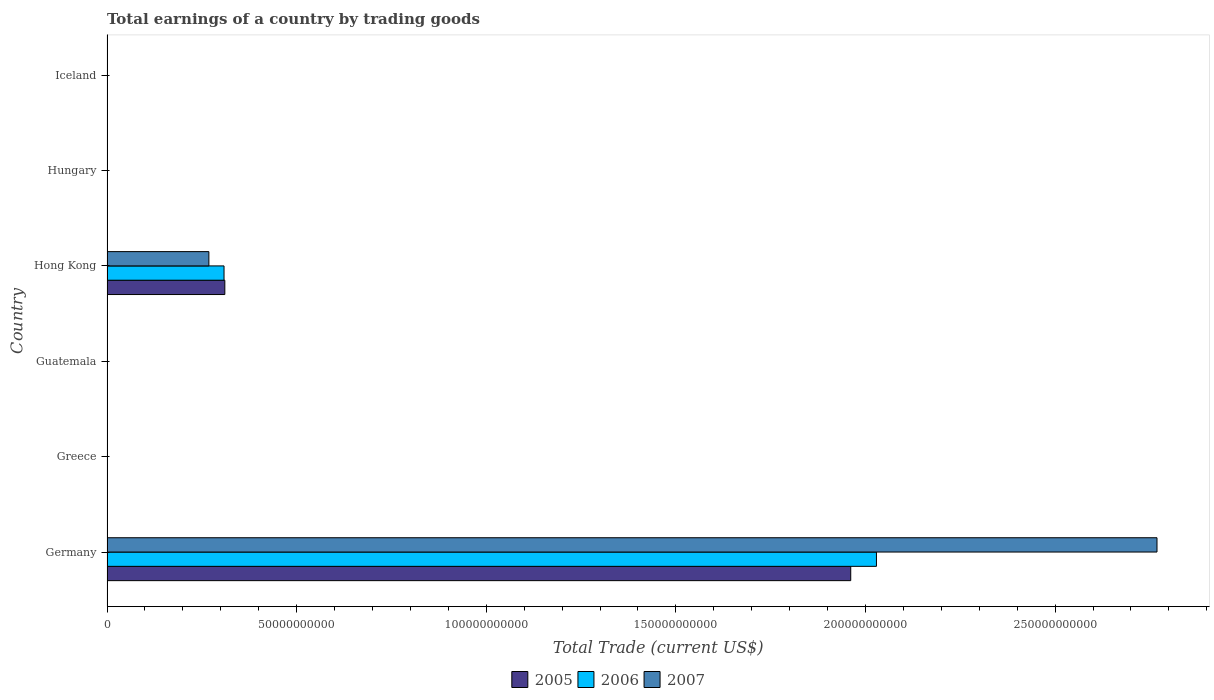How many bars are there on the 3rd tick from the top?
Your answer should be very brief. 3. How many bars are there on the 4th tick from the bottom?
Ensure brevity in your answer.  3. In how many cases, is the number of bars for a given country not equal to the number of legend labels?
Give a very brief answer. 4. What is the total earnings in 2007 in Germany?
Keep it short and to the point. 2.77e+11. Across all countries, what is the maximum total earnings in 2005?
Provide a succinct answer. 1.96e+11. What is the total total earnings in 2007 in the graph?
Your response must be concise. 3.04e+11. What is the difference between the total earnings in 2005 in Germany and that in Hong Kong?
Your answer should be very brief. 1.65e+11. What is the difference between the total earnings in 2006 in Hong Kong and the total earnings in 2005 in Iceland?
Provide a short and direct response. 3.09e+1. What is the average total earnings in 2005 per country?
Offer a very short reply. 3.79e+1. What is the difference between the total earnings in 2005 and total earnings in 2006 in Hong Kong?
Your answer should be very brief. 2.11e+08. What is the ratio of the total earnings in 2006 in Germany to that in Hong Kong?
Your answer should be very brief. 6.58. What is the difference between the highest and the lowest total earnings in 2005?
Provide a short and direct response. 1.96e+11. How many countries are there in the graph?
Your response must be concise. 6. Does the graph contain any zero values?
Offer a very short reply. Yes. Does the graph contain grids?
Provide a succinct answer. No. How many legend labels are there?
Provide a succinct answer. 3. How are the legend labels stacked?
Provide a succinct answer. Horizontal. What is the title of the graph?
Provide a succinct answer. Total earnings of a country by trading goods. Does "1963" appear as one of the legend labels in the graph?
Your answer should be very brief. No. What is the label or title of the X-axis?
Make the answer very short. Total Trade (current US$). What is the Total Trade (current US$) in 2005 in Germany?
Provide a short and direct response. 1.96e+11. What is the Total Trade (current US$) of 2006 in Germany?
Ensure brevity in your answer.  2.03e+11. What is the Total Trade (current US$) in 2007 in Germany?
Offer a terse response. 2.77e+11. What is the Total Trade (current US$) of 2005 in Guatemala?
Your answer should be compact. 0. What is the Total Trade (current US$) of 2006 in Guatemala?
Keep it short and to the point. 0. What is the Total Trade (current US$) in 2007 in Guatemala?
Keep it short and to the point. 0. What is the Total Trade (current US$) in 2005 in Hong Kong?
Your response must be concise. 3.11e+1. What is the Total Trade (current US$) in 2006 in Hong Kong?
Provide a succinct answer. 3.09e+1. What is the Total Trade (current US$) in 2007 in Hong Kong?
Offer a very short reply. 2.69e+1. What is the Total Trade (current US$) in 2006 in Hungary?
Offer a very short reply. 0. What is the Total Trade (current US$) of 2007 in Hungary?
Your answer should be very brief. 0. What is the Total Trade (current US$) of 2006 in Iceland?
Give a very brief answer. 0. Across all countries, what is the maximum Total Trade (current US$) in 2005?
Ensure brevity in your answer.  1.96e+11. Across all countries, what is the maximum Total Trade (current US$) in 2006?
Your answer should be very brief. 2.03e+11. Across all countries, what is the maximum Total Trade (current US$) of 2007?
Your response must be concise. 2.77e+11. What is the total Total Trade (current US$) of 2005 in the graph?
Keep it short and to the point. 2.27e+11. What is the total Total Trade (current US$) of 2006 in the graph?
Provide a short and direct response. 2.34e+11. What is the total Total Trade (current US$) in 2007 in the graph?
Offer a terse response. 3.04e+11. What is the difference between the Total Trade (current US$) in 2005 in Germany and that in Hong Kong?
Ensure brevity in your answer.  1.65e+11. What is the difference between the Total Trade (current US$) of 2006 in Germany and that in Hong Kong?
Provide a short and direct response. 1.72e+11. What is the difference between the Total Trade (current US$) in 2007 in Germany and that in Hong Kong?
Keep it short and to the point. 2.50e+11. What is the difference between the Total Trade (current US$) in 2005 in Germany and the Total Trade (current US$) in 2006 in Hong Kong?
Your response must be concise. 1.65e+11. What is the difference between the Total Trade (current US$) of 2005 in Germany and the Total Trade (current US$) of 2007 in Hong Kong?
Give a very brief answer. 1.69e+11. What is the difference between the Total Trade (current US$) in 2006 in Germany and the Total Trade (current US$) in 2007 in Hong Kong?
Make the answer very short. 1.76e+11. What is the average Total Trade (current US$) in 2005 per country?
Your answer should be compact. 3.79e+1. What is the average Total Trade (current US$) of 2006 per country?
Your response must be concise. 3.90e+1. What is the average Total Trade (current US$) in 2007 per country?
Provide a short and direct response. 5.06e+1. What is the difference between the Total Trade (current US$) in 2005 and Total Trade (current US$) in 2006 in Germany?
Offer a terse response. -6.78e+09. What is the difference between the Total Trade (current US$) of 2005 and Total Trade (current US$) of 2007 in Germany?
Your answer should be very brief. -8.08e+1. What is the difference between the Total Trade (current US$) of 2006 and Total Trade (current US$) of 2007 in Germany?
Provide a succinct answer. -7.40e+1. What is the difference between the Total Trade (current US$) of 2005 and Total Trade (current US$) of 2006 in Hong Kong?
Provide a succinct answer. 2.11e+08. What is the difference between the Total Trade (current US$) in 2005 and Total Trade (current US$) in 2007 in Hong Kong?
Your answer should be very brief. 4.21e+09. What is the difference between the Total Trade (current US$) in 2006 and Total Trade (current US$) in 2007 in Hong Kong?
Your response must be concise. 4.00e+09. What is the ratio of the Total Trade (current US$) of 2005 in Germany to that in Hong Kong?
Make the answer very short. 6.31. What is the ratio of the Total Trade (current US$) in 2006 in Germany to that in Hong Kong?
Offer a very short reply. 6.58. What is the ratio of the Total Trade (current US$) in 2007 in Germany to that in Hong Kong?
Your answer should be very brief. 10.31. What is the difference between the highest and the lowest Total Trade (current US$) of 2005?
Keep it short and to the point. 1.96e+11. What is the difference between the highest and the lowest Total Trade (current US$) in 2006?
Ensure brevity in your answer.  2.03e+11. What is the difference between the highest and the lowest Total Trade (current US$) in 2007?
Offer a terse response. 2.77e+11. 